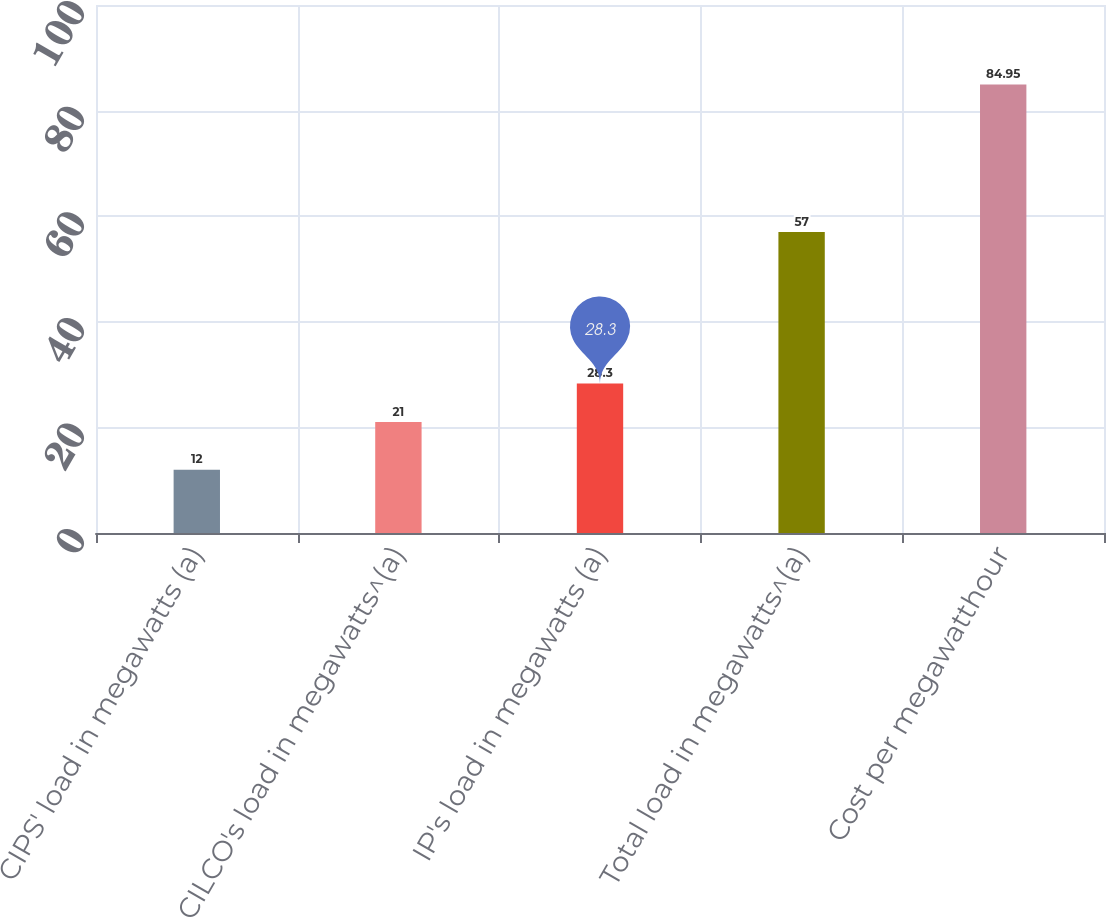Convert chart to OTSL. <chart><loc_0><loc_0><loc_500><loc_500><bar_chart><fcel>CIPS' load in megawatts (a)<fcel>CILCO's load in megawatts^(a)<fcel>IP's load in megawatts (a)<fcel>Total load in megawatts^(a)<fcel>Cost per megawatthour<nl><fcel>12<fcel>21<fcel>28.3<fcel>57<fcel>84.95<nl></chart> 